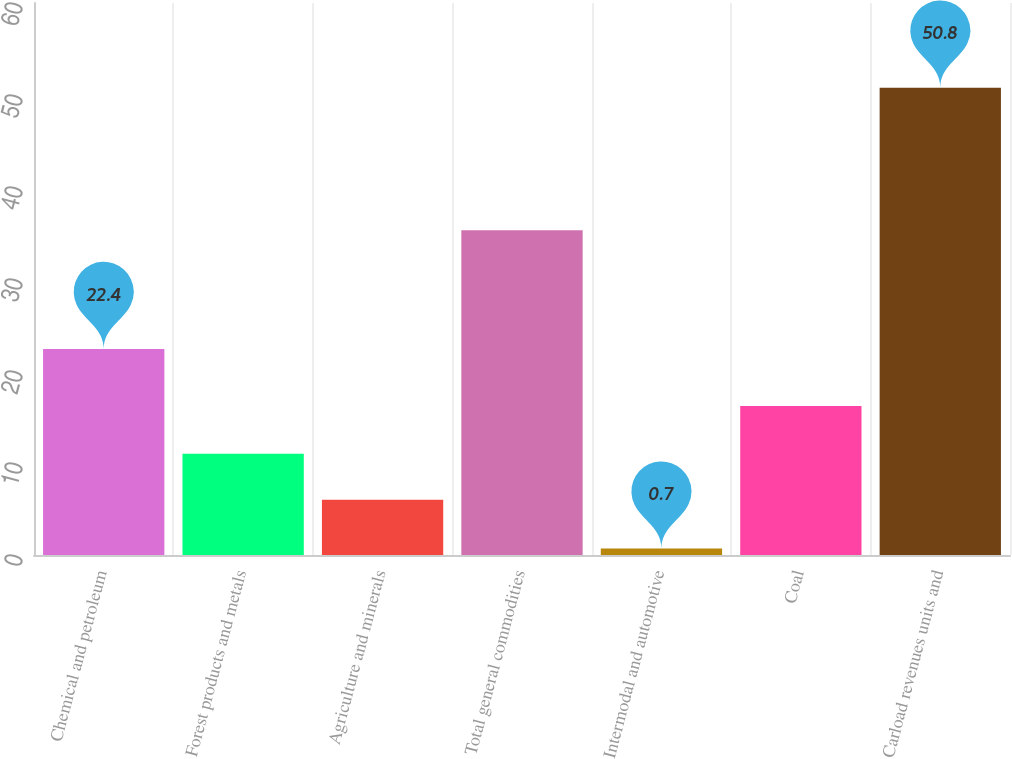Convert chart. <chart><loc_0><loc_0><loc_500><loc_500><bar_chart><fcel>Chemical and petroleum<fcel>Forest products and metals<fcel>Agriculture and minerals<fcel>Total general commodities<fcel>Intermodal and automotive<fcel>Coal<fcel>Carload revenues units and<nl><fcel>22.4<fcel>11.01<fcel>6<fcel>35.3<fcel>0.7<fcel>16.2<fcel>50.8<nl></chart> 